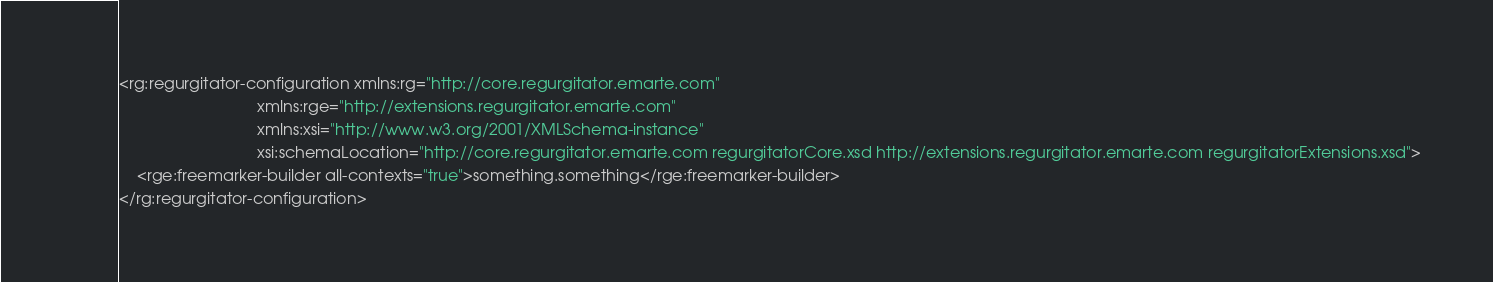Convert code to text. <code><loc_0><loc_0><loc_500><loc_500><_XML_><rg:regurgitator-configuration xmlns:rg="http://core.regurgitator.emarte.com"
                               xmlns:rge="http://extensions.regurgitator.emarte.com"
                               xmlns:xsi="http://www.w3.org/2001/XMLSchema-instance"
                               xsi:schemaLocation="http://core.regurgitator.emarte.com regurgitatorCore.xsd http://extensions.regurgitator.emarte.com regurgitatorExtensions.xsd">
    <rge:freemarker-builder all-contexts="true">something.something</rge:freemarker-builder>
</rg:regurgitator-configuration></code> 